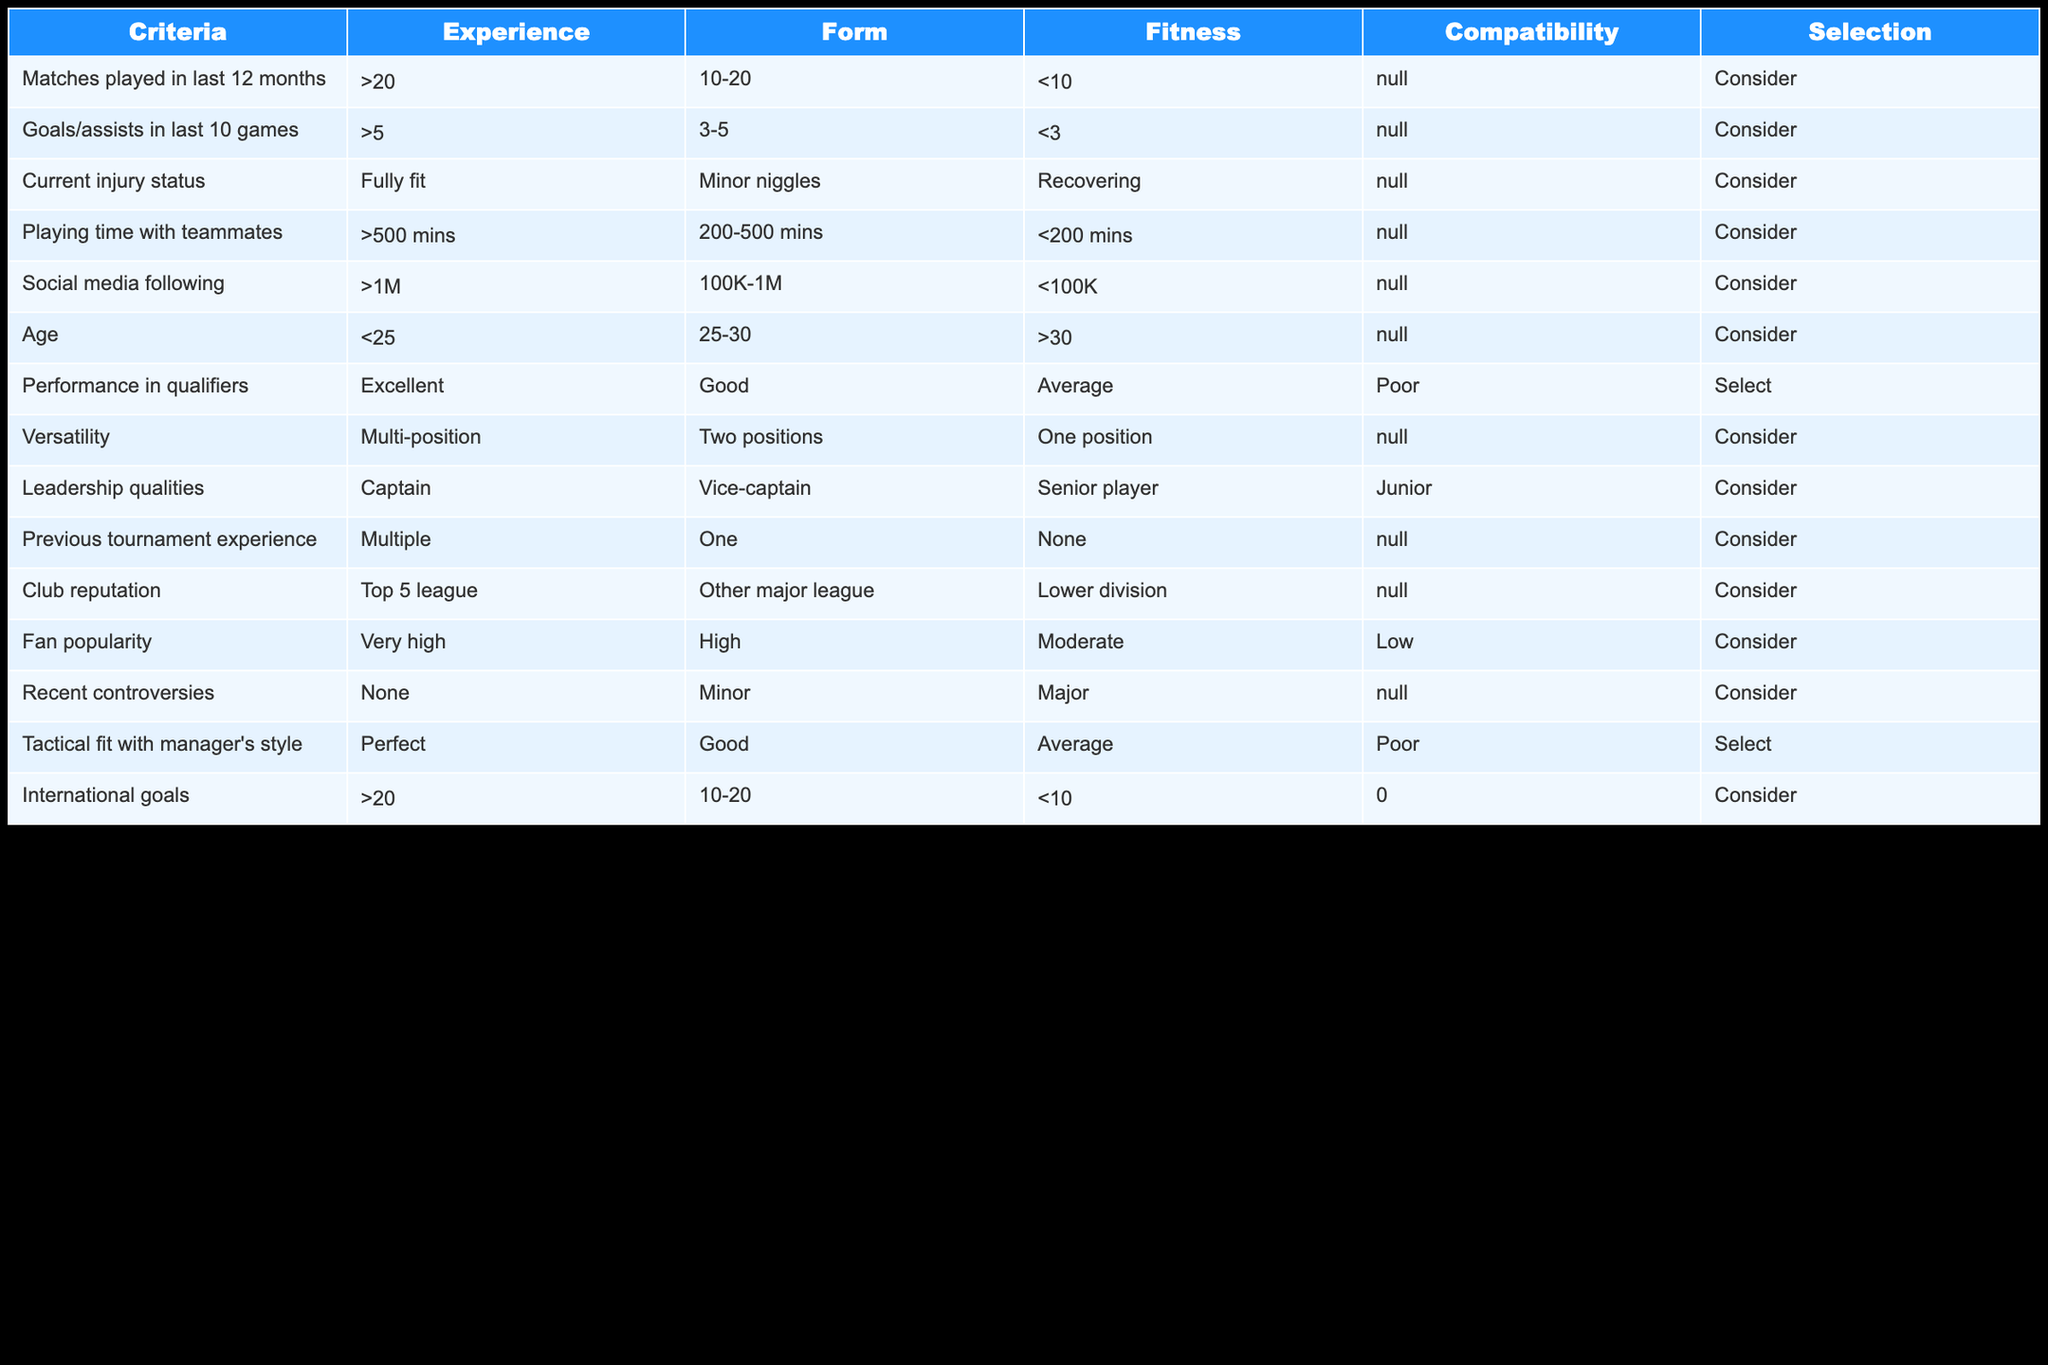What is the minimum age criterion for players? The age criterion mentions that players older than 30 years are categorized as "Consider," and anyone below this age has different status depending on their age group. Thus, the minimum age threshold is under 25 for selection.
Answer: Under 25 How many matches must a player have played in the last 12 months to be considered? According to the table, players who have played more than 20 matches in the last 12 months are to be considered, as marked by the criteria "Matches played in last 12 months."
Answer: More than 20 Is having a social media following less than 100K a criterion for selection? The criteria table indicates that less than 100K followers falls under "Consider," meaning it does not meet the selection criteria for players but can still be noted. Thus, such following does not grant a selection.
Answer: No What is the average number of goals/assists required in the last 10 games for a player to be considered? The criteria stipulate that players with between 3 and 5 goals/assists will be considered, while those with less than 3 will not. Thus, the average required would be closer to 4, which positions players on the edge of consideration.
Answer: 4 If a player is recovering from an injury, will they be selected? The criteria for current injury status shows that players who are recovering will not be selected as they fall under "Consider," not "Select" category. Therefore, being in recovery is a disqualifying condition.
Answer: No How many players should have experience in multiple previous tournaments to ensure their selection? The selection criterion states that players who have multiple tournament experiences are automatically selected, while having experience in just one or none does not guarantee selection. Hence, multiple experiences are required.
Answer: Multiple Does having more than 500 minutes of playtime with teammates guarantee a place in the team? The criteria suggest that having over 500 minutes is categorized under "Consider" but not "Select." Thus, while it increases the likelihood of consideration, it does not ensure a spot on the team.
Answer: No What is the relationship between tactical fit and player selection? The table indicates that players fitting perfectly within the manager's tactical style will be selected, while those graded lower will not ensure selection. Thus, being a tactical fit is crucial for selection.
Answer: Critical What is the selection criterion for players with a minor injury? Players with minor injuries are still listed under "Consider" which indicates that while they have a chance to be picked, it does not guarantee selection as full fitness is preferred.
Answer: Considered but not guaranteed 